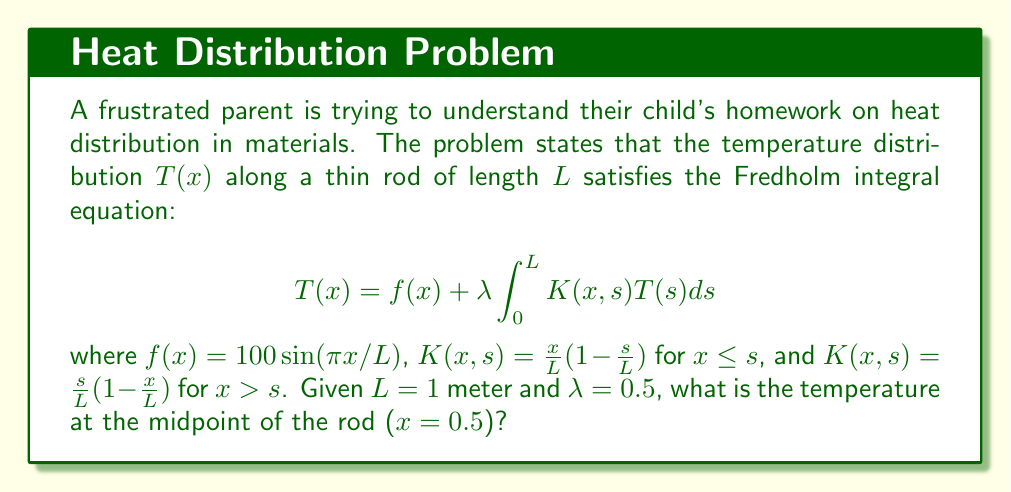Show me your answer to this math problem. Let's approach this step-by-step:

1) We need to solve the Fredholm integral equation for $T(0.5)$. The equation is:

   $$T(x) = f(x) + \lambda \int_0^L K(x,s)T(s)ds$$

2) We're given that $L = 1$ and $\lambda = 0.5$. At $x = 0.5$, $f(x) = 100\sin(\pi \cdot 0.5/1) = 100$

3) The kernel $K(x,s)$ is piecewise. For $x = 0.5$, we need to split the integral:

   $$T(0.5) = 100 + 0.5 \left[\int_0^{0.5} K(0.5,s)T(s)ds + \int_{0.5}^1 K(0.5,s)T(s)ds\right]$$

4) For the first integral ($0 \le s \le 0.5$), $K(0.5,s) = 0.5(1-s)$
   For the second integral ($0.5 < s \le 1$), $K(0.5,s) = s(1-0.5) = 0.5s$

5) Substituting:

   $$T(0.5) = 100 + 0.5 \left[\int_0^{0.5} 0.5(1-s)T(s)ds + \int_{0.5}^1 0.5sT(s)ds\right]$$

6) This is a complex integral equation. To solve it exactly, we would need to use advanced techniques like separable kernels or Neumann series. However, for a parent trying to help with homework, a numerical approximation might be more appropriate.

7) As a rough approximation, we can assume $T(s)$ is relatively constant near the middle of the rod. Let's call this constant $C$. Then:

   $$T(0.5) \approx 100 + 0.5C \left[\int_0^{0.5} 0.5(1-s)ds + \int_{0.5}^1 0.5sds\right]$$

8) Evaluating the integrals:

   $$T(0.5) \approx 100 + 0.5C \left[0.5(0.5 - 0.125) + 0.5(0.375)\right] = 100 + 0.09375C$$

9) If we assume $C \approx T(0.5)$, we can solve:

   $$T(0.5) \approx 100 + 0.09375T(0.5)$$
   $$0.90625T(0.5) \approx 100$$
   $$T(0.5) \approx 110.3$$

This is an approximation, but it gives us a reasonable estimate of the temperature at the midpoint of the rod.
Answer: $110.3$ °C (approximate) 